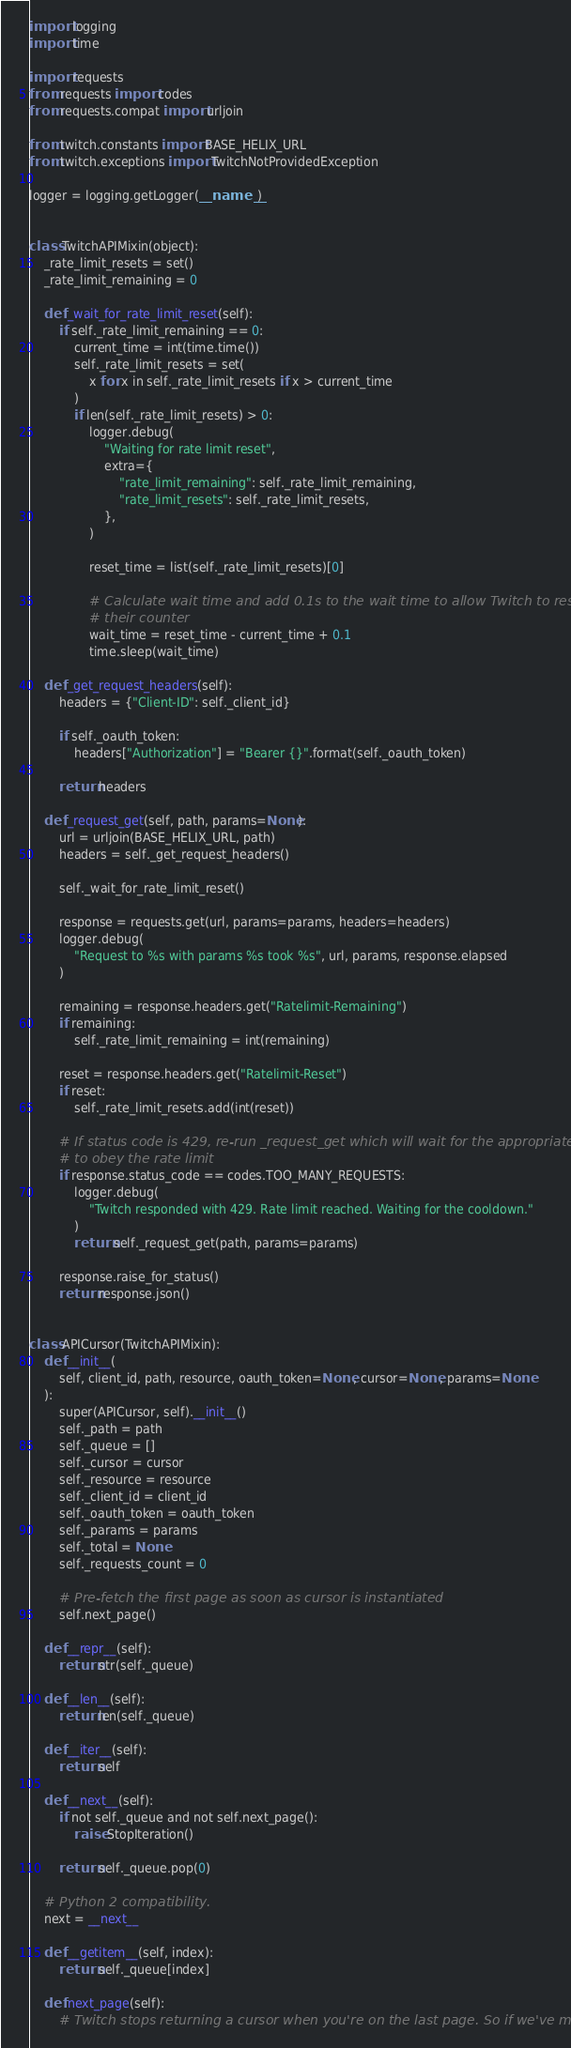<code> <loc_0><loc_0><loc_500><loc_500><_Python_>import logging
import time

import requests
from requests import codes
from requests.compat import urljoin

from twitch.constants import BASE_HELIX_URL
from twitch.exceptions import TwitchNotProvidedException

logger = logging.getLogger(__name__)


class TwitchAPIMixin(object):
    _rate_limit_resets = set()
    _rate_limit_remaining = 0

    def _wait_for_rate_limit_reset(self):
        if self._rate_limit_remaining == 0:
            current_time = int(time.time())
            self._rate_limit_resets = set(
                x for x in self._rate_limit_resets if x > current_time
            )
            if len(self._rate_limit_resets) > 0:
                logger.debug(
                    "Waiting for rate limit reset",
                    extra={
                        "rate_limit_remaining": self._rate_limit_remaining,
                        "rate_limit_resets": self._rate_limit_resets,
                    },
                )

                reset_time = list(self._rate_limit_resets)[0]

                # Calculate wait time and add 0.1s to the wait time to allow Twitch to reset
                # their counter
                wait_time = reset_time - current_time + 0.1
                time.sleep(wait_time)

    def _get_request_headers(self):
        headers = {"Client-ID": self._client_id}

        if self._oauth_token:
            headers["Authorization"] = "Bearer {}".format(self._oauth_token)

        return headers

    def _request_get(self, path, params=None):
        url = urljoin(BASE_HELIX_URL, path)
        headers = self._get_request_headers()

        self._wait_for_rate_limit_reset()

        response = requests.get(url, params=params, headers=headers)
        logger.debug(
            "Request to %s with params %s took %s", url, params, response.elapsed
        )

        remaining = response.headers.get("Ratelimit-Remaining")
        if remaining:
            self._rate_limit_remaining = int(remaining)

        reset = response.headers.get("Ratelimit-Reset")
        if reset:
            self._rate_limit_resets.add(int(reset))

        # If status code is 429, re-run _request_get which will wait for the appropriate time
        # to obey the rate limit
        if response.status_code == codes.TOO_MANY_REQUESTS:
            logger.debug(
                "Twitch responded with 429. Rate limit reached. Waiting for the cooldown."
            )
            return self._request_get(path, params=params)

        response.raise_for_status()
        return response.json()


class APICursor(TwitchAPIMixin):
    def __init__(
        self, client_id, path, resource, oauth_token=None, cursor=None, params=None
    ):
        super(APICursor, self).__init__()
        self._path = path
        self._queue = []
        self._cursor = cursor
        self._resource = resource
        self._client_id = client_id
        self._oauth_token = oauth_token
        self._params = params
        self._total = None
        self._requests_count = 0

        # Pre-fetch the first page as soon as cursor is instantiated
        self.next_page()

    def __repr__(self):
        return str(self._queue)

    def __len__(self):
        return len(self._queue)

    def __iter__(self):
        return self

    def __next__(self):
        if not self._queue and not self.next_page():
            raise StopIteration()

        return self._queue.pop(0)

    # Python 2 compatibility.
    next = __next__

    def __getitem__(self, index):
        return self._queue[index]

    def next_page(self):
        # Twitch stops returning a cursor when you're on the last page. So if we've made</code> 